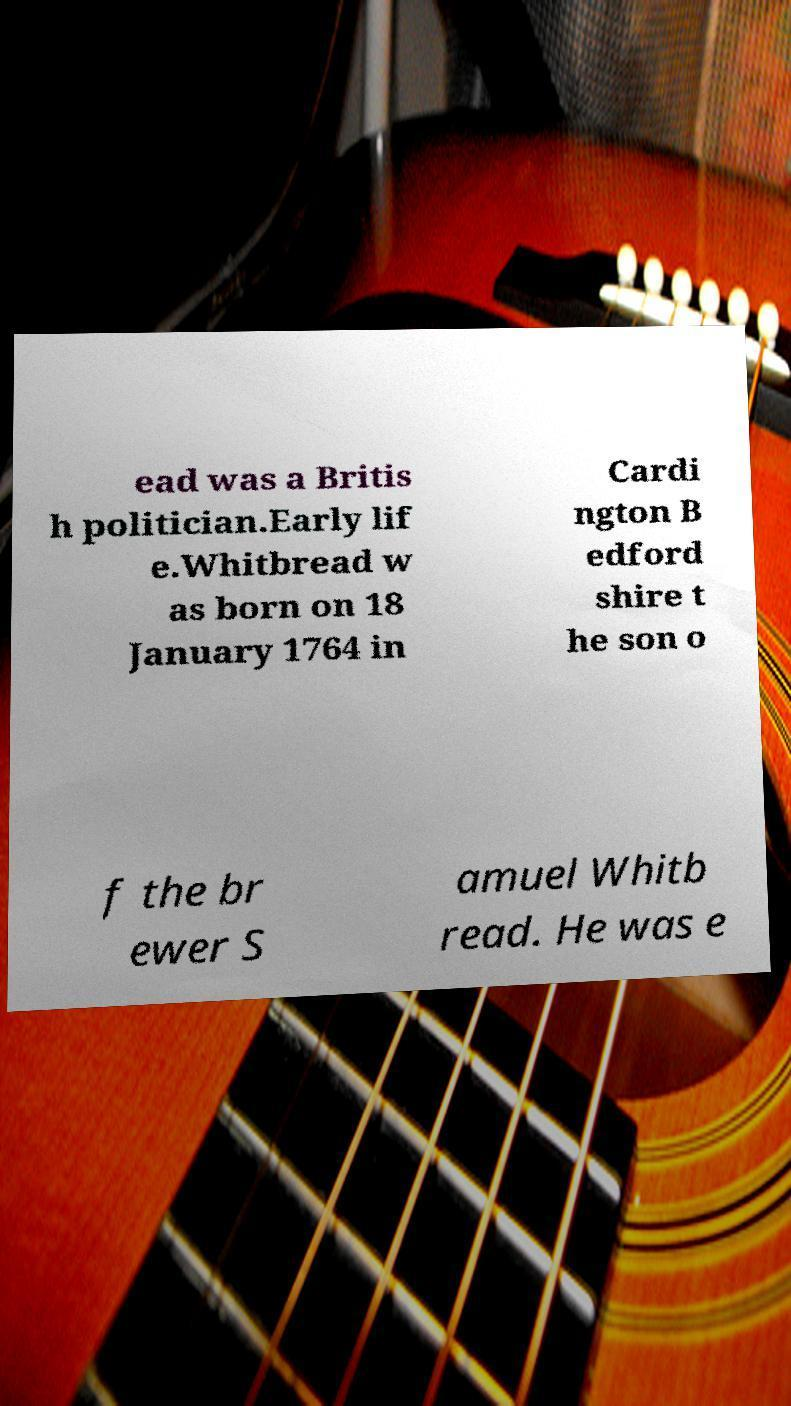Could you extract and type out the text from this image? ead was a Britis h politician.Early lif e.Whitbread w as born on 18 January 1764 in Cardi ngton B edford shire t he son o f the br ewer S amuel Whitb read. He was e 